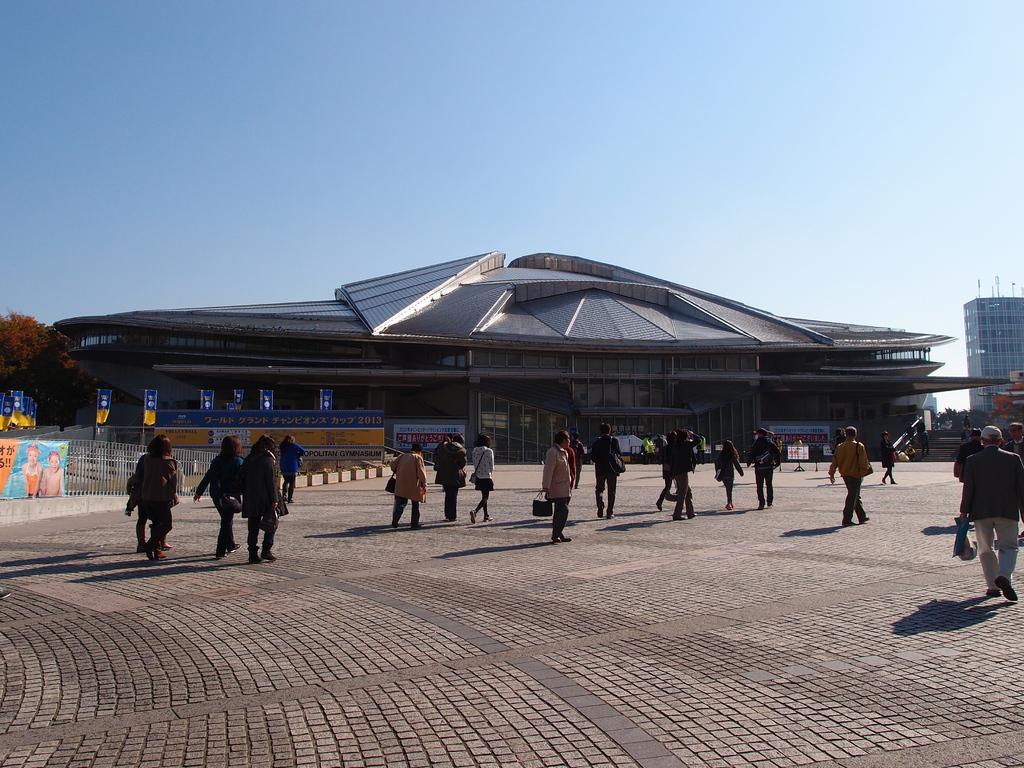Could you give a brief overview of what you see in this image? In this image we can see many people. Some are holding bags. In the back there are buildings. Also there are banners. On the left side there is a tree. In the background there is sky. 